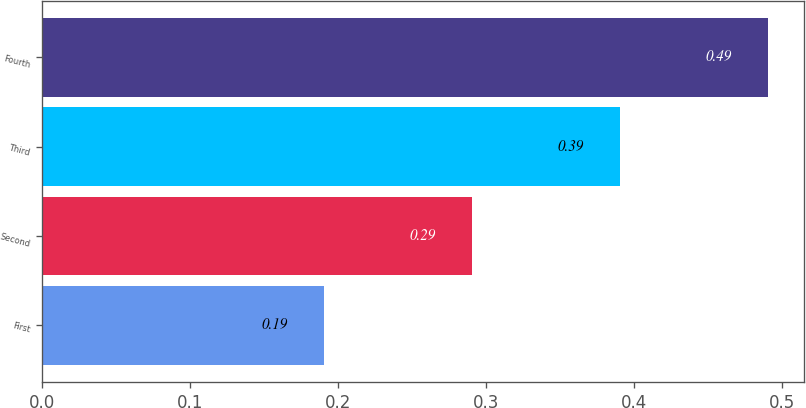Convert chart to OTSL. <chart><loc_0><loc_0><loc_500><loc_500><bar_chart><fcel>First<fcel>Second<fcel>Third<fcel>Fourth<nl><fcel>0.19<fcel>0.29<fcel>0.39<fcel>0.49<nl></chart> 